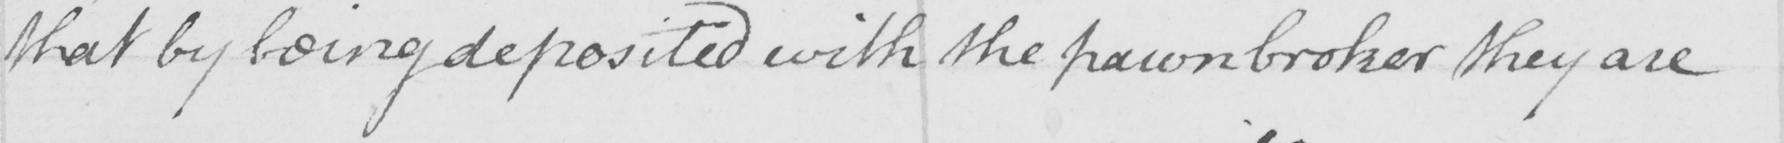Transcribe the text shown in this historical manuscript line. that by being deposited with the pawnbroker they are 